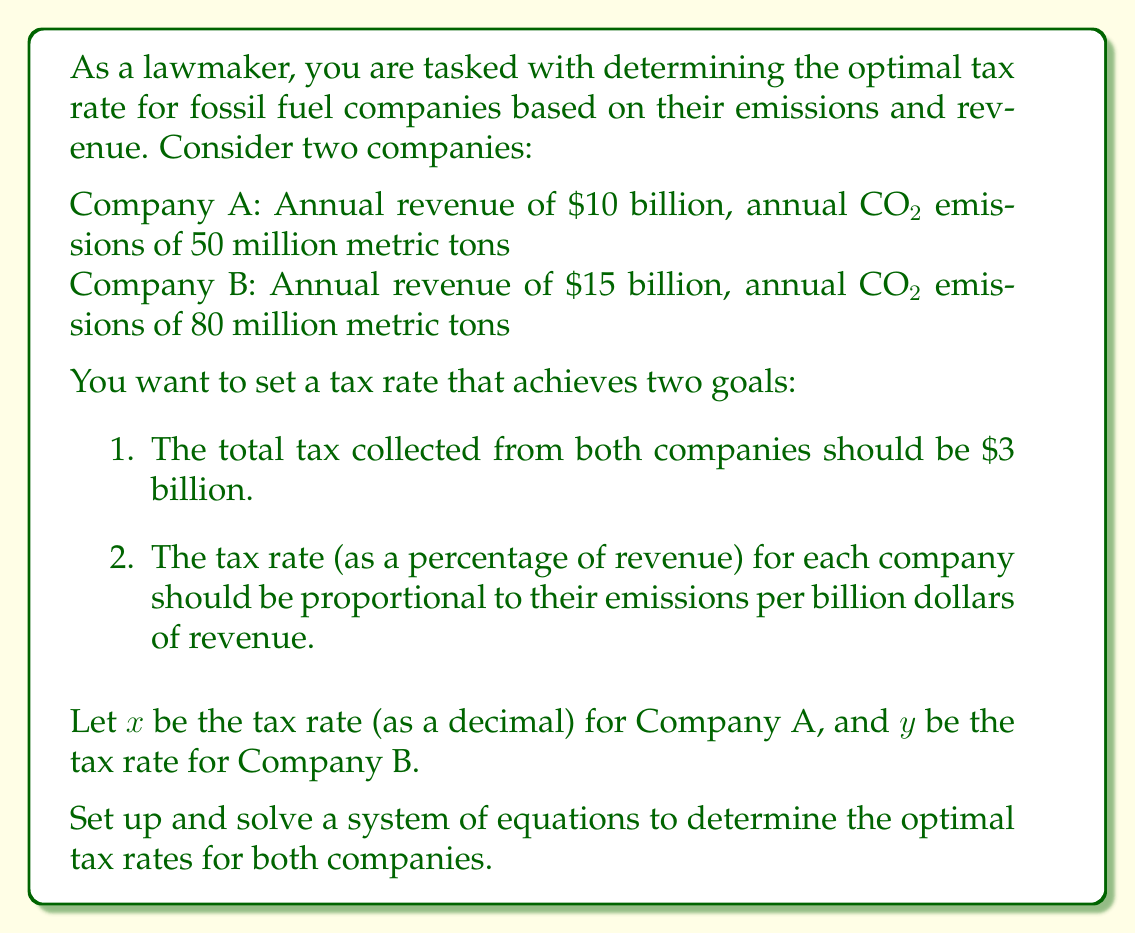Can you answer this question? Let's approach this problem step-by-step:

1) First, let's set up the equation for the total tax collected:

   $$10x + 15y = 3$$

   This ensures that the total tax collected from both companies is $3 billion.

2) Next, we need to set up the equation for the proportional tax rates. The emissions per billion dollars of revenue are:

   Company A: $50 / 10 = 5$ million metric tons per billion dollars
   Company B: $80 / 15 = 5.33$ million metric tons per billion dollars

   The tax rates should be proportional to these ratios:

   $$\frac{x}{5} = \frac{y}{5.33}$$

3) Cross-multiply to simplify this equation:

   $$5.33x = 5y$$

4) Now we have a system of two equations with two unknowns:

   $$\begin{cases}
   10x + 15y = 3 \\
   5.33x = 5y
   \end{cases}$$

5) Solve for $y$ in the second equation:

   $$y = \frac{5.33x}{5} = 1.066x$$

6) Substitute this into the first equation:

   $$10x + 15(1.066x) = 3$$
   $$10x + 15.99x = 3$$
   $$25.99x = 3$$

7) Solve for $x$:

   $$x = \frac{3}{25.99} \approx 0.1154$$

8) Now we can find $y$:

   $$y = 1.066x \approx 1.066 * 0.1154 \approx 0.1230$$

Therefore, the optimal tax rates are approximately 11.54% for Company A and 12.30% for Company B.
Answer: The optimal tax rates are:
Company A: 11.54%
Company B: 12.30% 